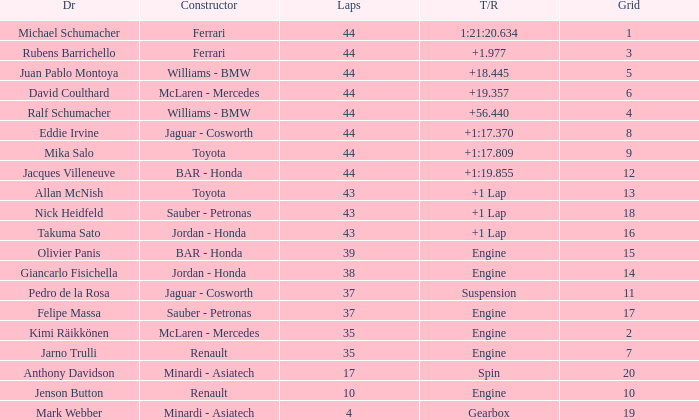What was the fewest laps for somone who finished +18.445? 44.0. 